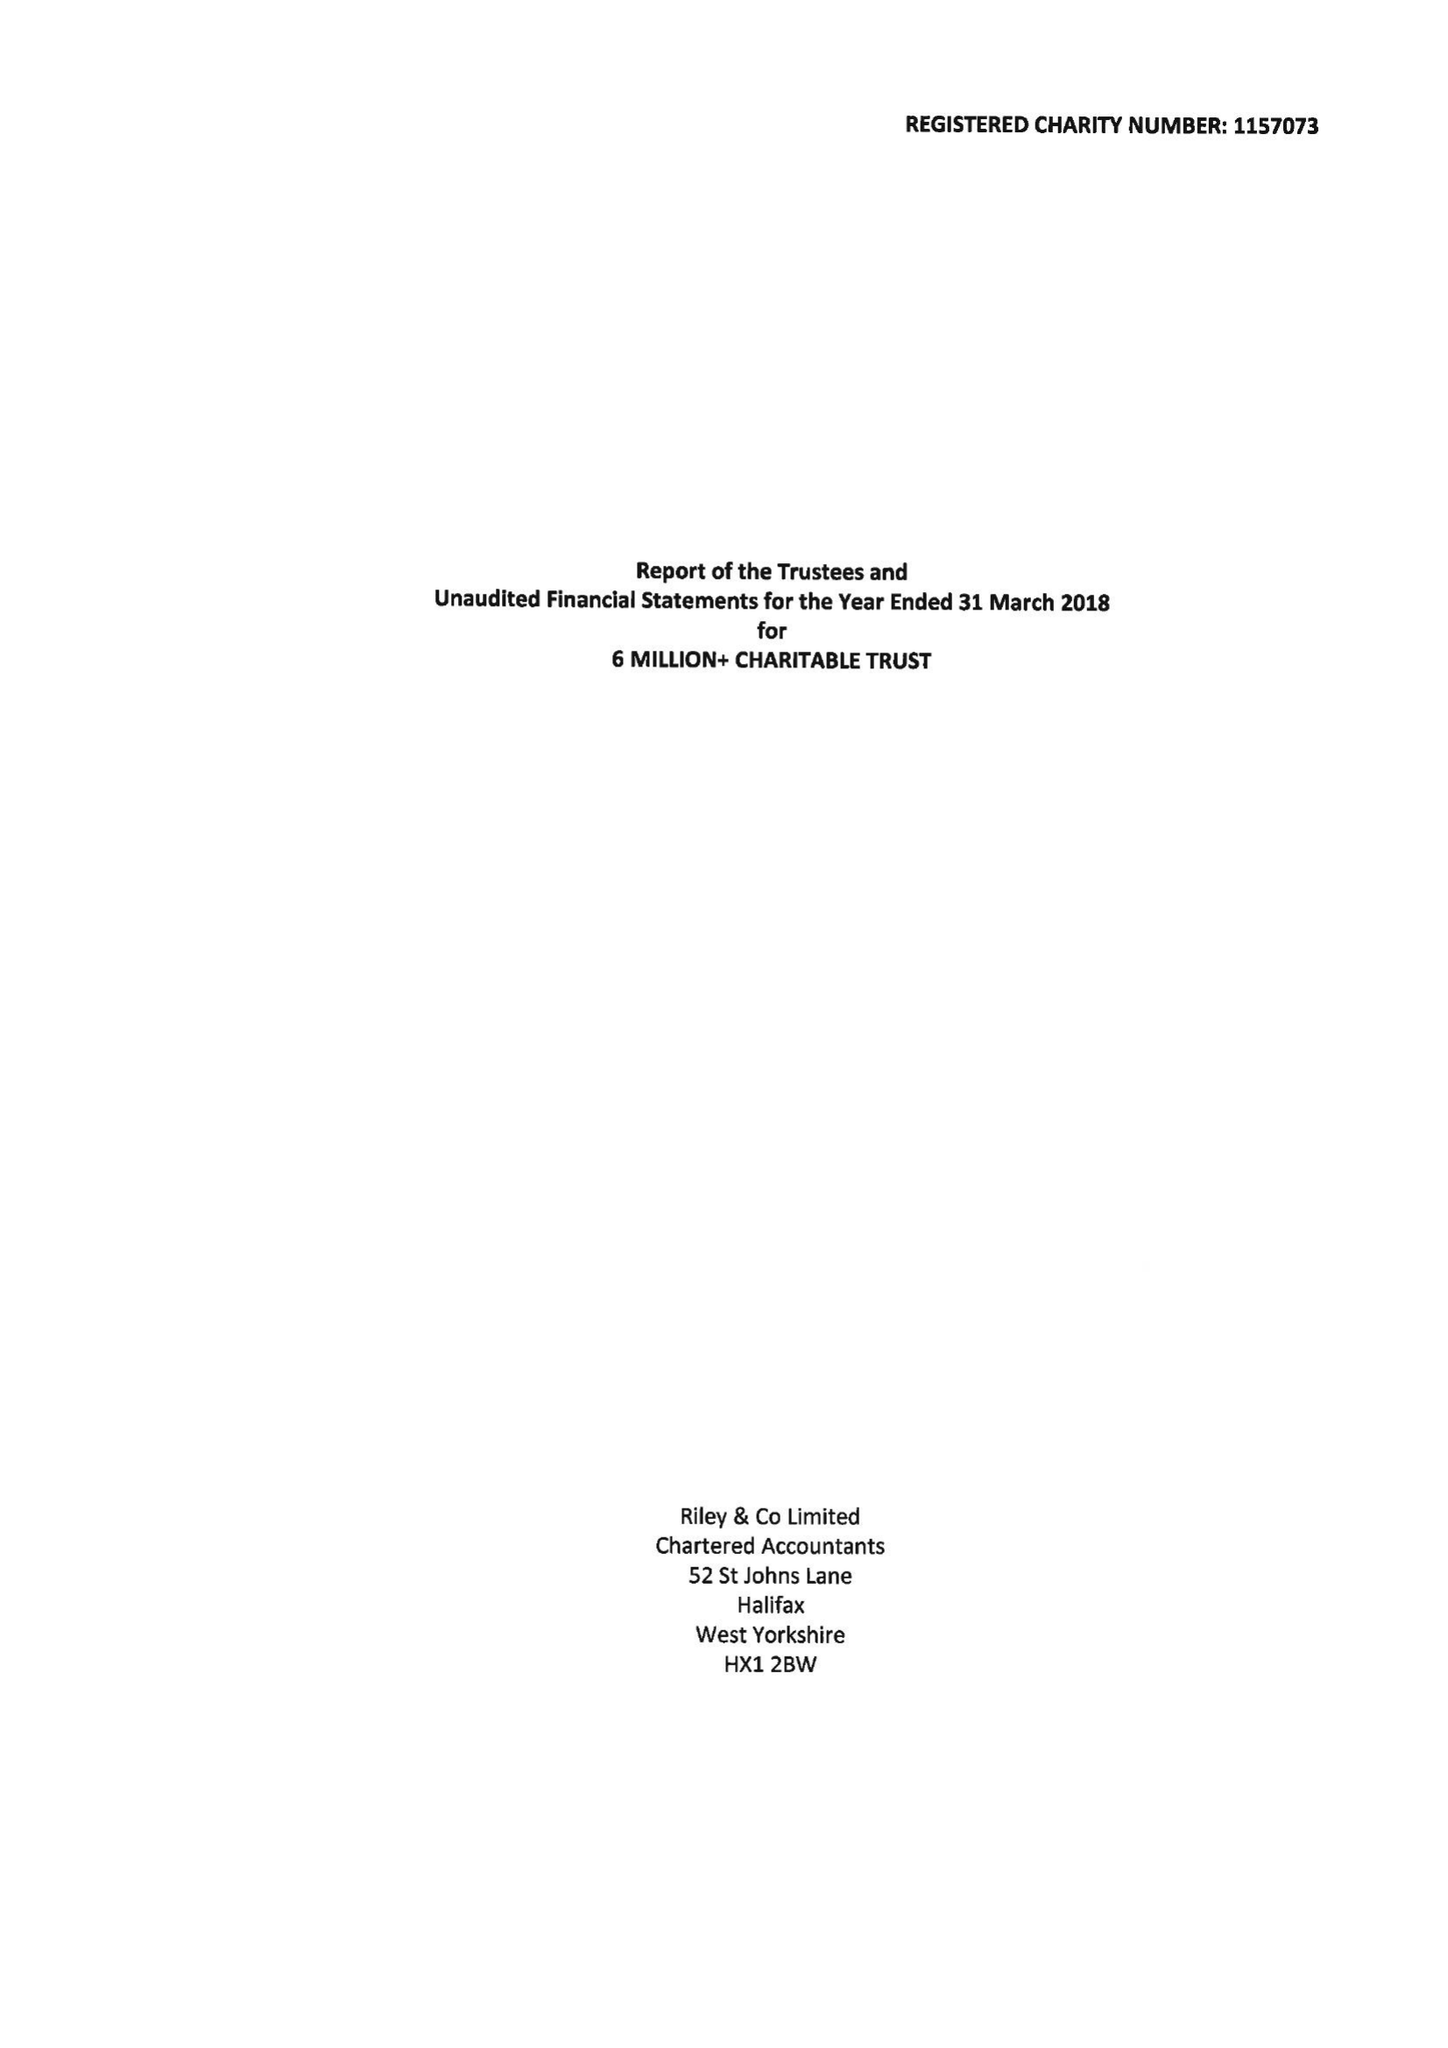What is the value for the income_annually_in_british_pounds?
Answer the question using a single word or phrase. 45640.00 